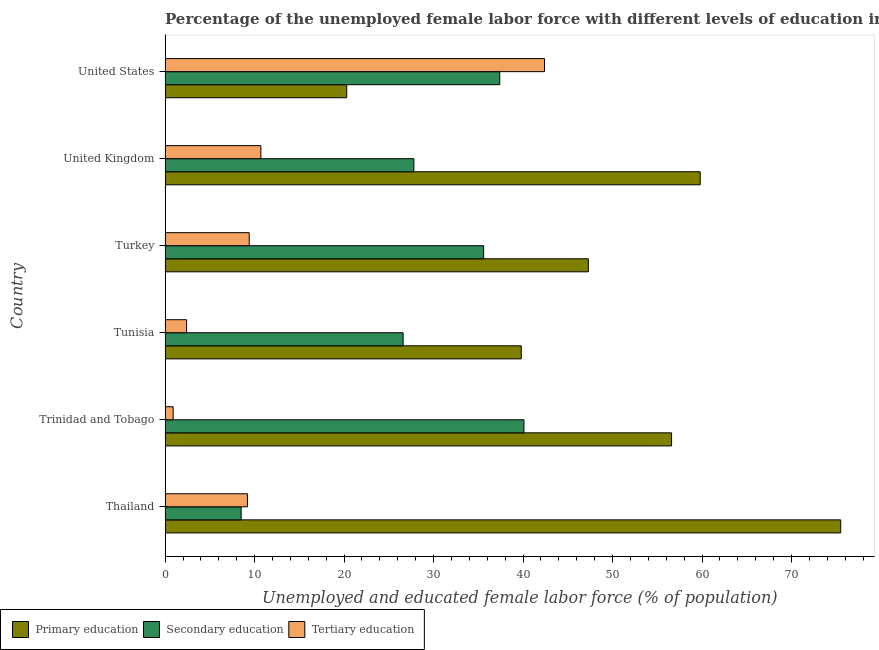How many different coloured bars are there?
Keep it short and to the point. 3. Are the number of bars per tick equal to the number of legend labels?
Your answer should be very brief. Yes. Are the number of bars on each tick of the Y-axis equal?
Give a very brief answer. Yes. In how many cases, is the number of bars for a given country not equal to the number of legend labels?
Provide a short and direct response. 0. What is the percentage of female labor force who received secondary education in Turkey?
Ensure brevity in your answer.  35.6. Across all countries, what is the maximum percentage of female labor force who received tertiary education?
Make the answer very short. 42.4. Across all countries, what is the minimum percentage of female labor force who received tertiary education?
Ensure brevity in your answer.  0.9. In which country was the percentage of female labor force who received primary education maximum?
Your answer should be very brief. Thailand. In which country was the percentage of female labor force who received secondary education minimum?
Provide a succinct answer. Thailand. What is the total percentage of female labor force who received tertiary education in the graph?
Your answer should be very brief. 75. What is the difference between the percentage of female labor force who received secondary education in Tunisia and that in United States?
Your answer should be compact. -10.8. What is the difference between the percentage of female labor force who received primary education in Thailand and the percentage of female labor force who received secondary education in United States?
Give a very brief answer. 38.1. What is the average percentage of female labor force who received primary education per country?
Your answer should be compact. 49.88. What is the difference between the percentage of female labor force who received tertiary education and percentage of female labor force who received primary education in Turkey?
Provide a succinct answer. -37.9. What is the ratio of the percentage of female labor force who received tertiary education in Tunisia to that in Turkey?
Ensure brevity in your answer.  0.26. Is the percentage of female labor force who received secondary education in Tunisia less than that in United States?
Provide a short and direct response. Yes. What is the difference between the highest and the second highest percentage of female labor force who received tertiary education?
Ensure brevity in your answer.  31.7. What is the difference between the highest and the lowest percentage of female labor force who received primary education?
Your answer should be very brief. 55.2. In how many countries, is the percentage of female labor force who received tertiary education greater than the average percentage of female labor force who received tertiary education taken over all countries?
Provide a succinct answer. 1. Is the sum of the percentage of female labor force who received primary education in Thailand and Tunisia greater than the maximum percentage of female labor force who received secondary education across all countries?
Provide a short and direct response. Yes. What does the 3rd bar from the top in Tunisia represents?
Give a very brief answer. Primary education. What does the 1st bar from the bottom in Tunisia represents?
Provide a short and direct response. Primary education. Is it the case that in every country, the sum of the percentage of female labor force who received primary education and percentage of female labor force who received secondary education is greater than the percentage of female labor force who received tertiary education?
Your response must be concise. Yes. How many bars are there?
Ensure brevity in your answer.  18. Are all the bars in the graph horizontal?
Your answer should be very brief. Yes. How many countries are there in the graph?
Provide a short and direct response. 6. What is the difference between two consecutive major ticks on the X-axis?
Offer a very short reply. 10. Does the graph contain any zero values?
Provide a short and direct response. No. Where does the legend appear in the graph?
Your answer should be very brief. Bottom left. What is the title of the graph?
Offer a terse response. Percentage of the unemployed female labor force with different levels of education in countries. What is the label or title of the X-axis?
Your response must be concise. Unemployed and educated female labor force (% of population). What is the label or title of the Y-axis?
Your answer should be very brief. Country. What is the Unemployed and educated female labor force (% of population) of Primary education in Thailand?
Keep it short and to the point. 75.5. What is the Unemployed and educated female labor force (% of population) of Secondary education in Thailand?
Your response must be concise. 8.5. What is the Unemployed and educated female labor force (% of population) in Tertiary education in Thailand?
Offer a very short reply. 9.2. What is the Unemployed and educated female labor force (% of population) in Primary education in Trinidad and Tobago?
Your answer should be compact. 56.6. What is the Unemployed and educated female labor force (% of population) in Secondary education in Trinidad and Tobago?
Keep it short and to the point. 40.1. What is the Unemployed and educated female labor force (% of population) of Tertiary education in Trinidad and Tobago?
Offer a very short reply. 0.9. What is the Unemployed and educated female labor force (% of population) of Primary education in Tunisia?
Offer a terse response. 39.8. What is the Unemployed and educated female labor force (% of population) of Secondary education in Tunisia?
Your response must be concise. 26.6. What is the Unemployed and educated female labor force (% of population) in Tertiary education in Tunisia?
Offer a terse response. 2.4. What is the Unemployed and educated female labor force (% of population) of Primary education in Turkey?
Keep it short and to the point. 47.3. What is the Unemployed and educated female labor force (% of population) of Secondary education in Turkey?
Your answer should be compact. 35.6. What is the Unemployed and educated female labor force (% of population) in Tertiary education in Turkey?
Offer a terse response. 9.4. What is the Unemployed and educated female labor force (% of population) in Primary education in United Kingdom?
Give a very brief answer. 59.8. What is the Unemployed and educated female labor force (% of population) of Secondary education in United Kingdom?
Offer a terse response. 27.8. What is the Unemployed and educated female labor force (% of population) of Tertiary education in United Kingdom?
Your answer should be very brief. 10.7. What is the Unemployed and educated female labor force (% of population) of Primary education in United States?
Offer a terse response. 20.3. What is the Unemployed and educated female labor force (% of population) of Secondary education in United States?
Offer a very short reply. 37.4. What is the Unemployed and educated female labor force (% of population) of Tertiary education in United States?
Your answer should be compact. 42.4. Across all countries, what is the maximum Unemployed and educated female labor force (% of population) of Primary education?
Give a very brief answer. 75.5. Across all countries, what is the maximum Unemployed and educated female labor force (% of population) in Secondary education?
Your response must be concise. 40.1. Across all countries, what is the maximum Unemployed and educated female labor force (% of population) of Tertiary education?
Ensure brevity in your answer.  42.4. Across all countries, what is the minimum Unemployed and educated female labor force (% of population) in Primary education?
Offer a terse response. 20.3. Across all countries, what is the minimum Unemployed and educated female labor force (% of population) of Tertiary education?
Offer a very short reply. 0.9. What is the total Unemployed and educated female labor force (% of population) in Primary education in the graph?
Ensure brevity in your answer.  299.3. What is the total Unemployed and educated female labor force (% of population) of Secondary education in the graph?
Ensure brevity in your answer.  176. What is the difference between the Unemployed and educated female labor force (% of population) in Primary education in Thailand and that in Trinidad and Tobago?
Your answer should be compact. 18.9. What is the difference between the Unemployed and educated female labor force (% of population) of Secondary education in Thailand and that in Trinidad and Tobago?
Give a very brief answer. -31.6. What is the difference between the Unemployed and educated female labor force (% of population) in Tertiary education in Thailand and that in Trinidad and Tobago?
Your answer should be very brief. 8.3. What is the difference between the Unemployed and educated female labor force (% of population) in Primary education in Thailand and that in Tunisia?
Keep it short and to the point. 35.7. What is the difference between the Unemployed and educated female labor force (% of population) of Secondary education in Thailand and that in Tunisia?
Ensure brevity in your answer.  -18.1. What is the difference between the Unemployed and educated female labor force (% of population) of Primary education in Thailand and that in Turkey?
Keep it short and to the point. 28.2. What is the difference between the Unemployed and educated female labor force (% of population) in Secondary education in Thailand and that in Turkey?
Make the answer very short. -27.1. What is the difference between the Unemployed and educated female labor force (% of population) in Tertiary education in Thailand and that in Turkey?
Offer a terse response. -0.2. What is the difference between the Unemployed and educated female labor force (% of population) of Secondary education in Thailand and that in United Kingdom?
Offer a very short reply. -19.3. What is the difference between the Unemployed and educated female labor force (% of population) in Tertiary education in Thailand and that in United Kingdom?
Offer a very short reply. -1.5. What is the difference between the Unemployed and educated female labor force (% of population) of Primary education in Thailand and that in United States?
Your answer should be compact. 55.2. What is the difference between the Unemployed and educated female labor force (% of population) of Secondary education in Thailand and that in United States?
Give a very brief answer. -28.9. What is the difference between the Unemployed and educated female labor force (% of population) in Tertiary education in Thailand and that in United States?
Make the answer very short. -33.2. What is the difference between the Unemployed and educated female labor force (% of population) of Primary education in Trinidad and Tobago and that in Tunisia?
Your response must be concise. 16.8. What is the difference between the Unemployed and educated female labor force (% of population) in Secondary education in Trinidad and Tobago and that in Tunisia?
Your response must be concise. 13.5. What is the difference between the Unemployed and educated female labor force (% of population) in Tertiary education in Trinidad and Tobago and that in Turkey?
Your answer should be compact. -8.5. What is the difference between the Unemployed and educated female labor force (% of population) of Secondary education in Trinidad and Tobago and that in United Kingdom?
Ensure brevity in your answer.  12.3. What is the difference between the Unemployed and educated female labor force (% of population) of Tertiary education in Trinidad and Tobago and that in United Kingdom?
Give a very brief answer. -9.8. What is the difference between the Unemployed and educated female labor force (% of population) of Primary education in Trinidad and Tobago and that in United States?
Ensure brevity in your answer.  36.3. What is the difference between the Unemployed and educated female labor force (% of population) of Tertiary education in Trinidad and Tobago and that in United States?
Provide a short and direct response. -41.5. What is the difference between the Unemployed and educated female labor force (% of population) in Tertiary education in Tunisia and that in Turkey?
Make the answer very short. -7. What is the difference between the Unemployed and educated female labor force (% of population) of Primary education in Tunisia and that in United Kingdom?
Ensure brevity in your answer.  -20. What is the difference between the Unemployed and educated female labor force (% of population) of Tertiary education in Tunisia and that in United Kingdom?
Your answer should be very brief. -8.3. What is the difference between the Unemployed and educated female labor force (% of population) in Tertiary education in Tunisia and that in United States?
Give a very brief answer. -40. What is the difference between the Unemployed and educated female labor force (% of population) in Primary education in Turkey and that in United Kingdom?
Offer a terse response. -12.5. What is the difference between the Unemployed and educated female labor force (% of population) of Secondary education in Turkey and that in United Kingdom?
Provide a short and direct response. 7.8. What is the difference between the Unemployed and educated female labor force (% of population) of Secondary education in Turkey and that in United States?
Your answer should be very brief. -1.8. What is the difference between the Unemployed and educated female labor force (% of population) of Tertiary education in Turkey and that in United States?
Keep it short and to the point. -33. What is the difference between the Unemployed and educated female labor force (% of population) of Primary education in United Kingdom and that in United States?
Give a very brief answer. 39.5. What is the difference between the Unemployed and educated female labor force (% of population) of Tertiary education in United Kingdom and that in United States?
Your response must be concise. -31.7. What is the difference between the Unemployed and educated female labor force (% of population) in Primary education in Thailand and the Unemployed and educated female labor force (% of population) in Secondary education in Trinidad and Tobago?
Your answer should be compact. 35.4. What is the difference between the Unemployed and educated female labor force (% of population) of Primary education in Thailand and the Unemployed and educated female labor force (% of population) of Tertiary education in Trinidad and Tobago?
Offer a very short reply. 74.6. What is the difference between the Unemployed and educated female labor force (% of population) of Secondary education in Thailand and the Unemployed and educated female labor force (% of population) of Tertiary education in Trinidad and Tobago?
Offer a very short reply. 7.6. What is the difference between the Unemployed and educated female labor force (% of population) of Primary education in Thailand and the Unemployed and educated female labor force (% of population) of Secondary education in Tunisia?
Your response must be concise. 48.9. What is the difference between the Unemployed and educated female labor force (% of population) in Primary education in Thailand and the Unemployed and educated female labor force (% of population) in Tertiary education in Tunisia?
Ensure brevity in your answer.  73.1. What is the difference between the Unemployed and educated female labor force (% of population) in Primary education in Thailand and the Unemployed and educated female labor force (% of population) in Secondary education in Turkey?
Provide a short and direct response. 39.9. What is the difference between the Unemployed and educated female labor force (% of population) in Primary education in Thailand and the Unemployed and educated female labor force (% of population) in Tertiary education in Turkey?
Ensure brevity in your answer.  66.1. What is the difference between the Unemployed and educated female labor force (% of population) of Primary education in Thailand and the Unemployed and educated female labor force (% of population) of Secondary education in United Kingdom?
Provide a short and direct response. 47.7. What is the difference between the Unemployed and educated female labor force (% of population) of Primary education in Thailand and the Unemployed and educated female labor force (% of population) of Tertiary education in United Kingdom?
Give a very brief answer. 64.8. What is the difference between the Unemployed and educated female labor force (% of population) of Secondary education in Thailand and the Unemployed and educated female labor force (% of population) of Tertiary education in United Kingdom?
Provide a short and direct response. -2.2. What is the difference between the Unemployed and educated female labor force (% of population) in Primary education in Thailand and the Unemployed and educated female labor force (% of population) in Secondary education in United States?
Make the answer very short. 38.1. What is the difference between the Unemployed and educated female labor force (% of population) of Primary education in Thailand and the Unemployed and educated female labor force (% of population) of Tertiary education in United States?
Your answer should be compact. 33.1. What is the difference between the Unemployed and educated female labor force (% of population) of Secondary education in Thailand and the Unemployed and educated female labor force (% of population) of Tertiary education in United States?
Offer a terse response. -33.9. What is the difference between the Unemployed and educated female labor force (% of population) of Primary education in Trinidad and Tobago and the Unemployed and educated female labor force (% of population) of Tertiary education in Tunisia?
Provide a succinct answer. 54.2. What is the difference between the Unemployed and educated female labor force (% of population) in Secondary education in Trinidad and Tobago and the Unemployed and educated female labor force (% of population) in Tertiary education in Tunisia?
Your answer should be compact. 37.7. What is the difference between the Unemployed and educated female labor force (% of population) in Primary education in Trinidad and Tobago and the Unemployed and educated female labor force (% of population) in Secondary education in Turkey?
Provide a short and direct response. 21. What is the difference between the Unemployed and educated female labor force (% of population) of Primary education in Trinidad and Tobago and the Unemployed and educated female labor force (% of population) of Tertiary education in Turkey?
Your response must be concise. 47.2. What is the difference between the Unemployed and educated female labor force (% of population) of Secondary education in Trinidad and Tobago and the Unemployed and educated female labor force (% of population) of Tertiary education in Turkey?
Offer a very short reply. 30.7. What is the difference between the Unemployed and educated female labor force (% of population) of Primary education in Trinidad and Tobago and the Unemployed and educated female labor force (% of population) of Secondary education in United Kingdom?
Your response must be concise. 28.8. What is the difference between the Unemployed and educated female labor force (% of population) in Primary education in Trinidad and Tobago and the Unemployed and educated female labor force (% of population) in Tertiary education in United Kingdom?
Provide a succinct answer. 45.9. What is the difference between the Unemployed and educated female labor force (% of population) of Secondary education in Trinidad and Tobago and the Unemployed and educated female labor force (% of population) of Tertiary education in United Kingdom?
Your answer should be compact. 29.4. What is the difference between the Unemployed and educated female labor force (% of population) in Primary education in Trinidad and Tobago and the Unemployed and educated female labor force (% of population) in Secondary education in United States?
Your answer should be compact. 19.2. What is the difference between the Unemployed and educated female labor force (% of population) in Primary education in Trinidad and Tobago and the Unemployed and educated female labor force (% of population) in Tertiary education in United States?
Give a very brief answer. 14.2. What is the difference between the Unemployed and educated female labor force (% of population) in Primary education in Tunisia and the Unemployed and educated female labor force (% of population) in Tertiary education in Turkey?
Give a very brief answer. 30.4. What is the difference between the Unemployed and educated female labor force (% of population) in Primary education in Tunisia and the Unemployed and educated female labor force (% of population) in Secondary education in United Kingdom?
Your answer should be compact. 12. What is the difference between the Unemployed and educated female labor force (% of population) of Primary education in Tunisia and the Unemployed and educated female labor force (% of population) of Tertiary education in United Kingdom?
Offer a very short reply. 29.1. What is the difference between the Unemployed and educated female labor force (% of population) in Secondary education in Tunisia and the Unemployed and educated female labor force (% of population) in Tertiary education in United Kingdom?
Your answer should be compact. 15.9. What is the difference between the Unemployed and educated female labor force (% of population) in Primary education in Tunisia and the Unemployed and educated female labor force (% of population) in Secondary education in United States?
Provide a succinct answer. 2.4. What is the difference between the Unemployed and educated female labor force (% of population) in Primary education in Tunisia and the Unemployed and educated female labor force (% of population) in Tertiary education in United States?
Your response must be concise. -2.6. What is the difference between the Unemployed and educated female labor force (% of population) in Secondary education in Tunisia and the Unemployed and educated female labor force (% of population) in Tertiary education in United States?
Offer a terse response. -15.8. What is the difference between the Unemployed and educated female labor force (% of population) of Primary education in Turkey and the Unemployed and educated female labor force (% of population) of Secondary education in United Kingdom?
Give a very brief answer. 19.5. What is the difference between the Unemployed and educated female labor force (% of population) of Primary education in Turkey and the Unemployed and educated female labor force (% of population) of Tertiary education in United Kingdom?
Make the answer very short. 36.6. What is the difference between the Unemployed and educated female labor force (% of population) of Secondary education in Turkey and the Unemployed and educated female labor force (% of population) of Tertiary education in United Kingdom?
Give a very brief answer. 24.9. What is the difference between the Unemployed and educated female labor force (% of population) in Primary education in Turkey and the Unemployed and educated female labor force (% of population) in Tertiary education in United States?
Make the answer very short. 4.9. What is the difference between the Unemployed and educated female labor force (% of population) in Primary education in United Kingdom and the Unemployed and educated female labor force (% of population) in Secondary education in United States?
Your response must be concise. 22.4. What is the difference between the Unemployed and educated female labor force (% of population) in Primary education in United Kingdom and the Unemployed and educated female labor force (% of population) in Tertiary education in United States?
Make the answer very short. 17.4. What is the difference between the Unemployed and educated female labor force (% of population) in Secondary education in United Kingdom and the Unemployed and educated female labor force (% of population) in Tertiary education in United States?
Make the answer very short. -14.6. What is the average Unemployed and educated female labor force (% of population) of Primary education per country?
Your response must be concise. 49.88. What is the average Unemployed and educated female labor force (% of population) of Secondary education per country?
Ensure brevity in your answer.  29.33. What is the difference between the Unemployed and educated female labor force (% of population) in Primary education and Unemployed and educated female labor force (% of population) in Secondary education in Thailand?
Your answer should be very brief. 67. What is the difference between the Unemployed and educated female labor force (% of population) of Primary education and Unemployed and educated female labor force (% of population) of Tertiary education in Thailand?
Offer a very short reply. 66.3. What is the difference between the Unemployed and educated female labor force (% of population) of Primary education and Unemployed and educated female labor force (% of population) of Secondary education in Trinidad and Tobago?
Your response must be concise. 16.5. What is the difference between the Unemployed and educated female labor force (% of population) of Primary education and Unemployed and educated female labor force (% of population) of Tertiary education in Trinidad and Tobago?
Give a very brief answer. 55.7. What is the difference between the Unemployed and educated female labor force (% of population) of Secondary education and Unemployed and educated female labor force (% of population) of Tertiary education in Trinidad and Tobago?
Give a very brief answer. 39.2. What is the difference between the Unemployed and educated female labor force (% of population) of Primary education and Unemployed and educated female labor force (% of population) of Tertiary education in Tunisia?
Provide a short and direct response. 37.4. What is the difference between the Unemployed and educated female labor force (% of population) of Secondary education and Unemployed and educated female labor force (% of population) of Tertiary education in Tunisia?
Offer a very short reply. 24.2. What is the difference between the Unemployed and educated female labor force (% of population) of Primary education and Unemployed and educated female labor force (% of population) of Tertiary education in Turkey?
Your response must be concise. 37.9. What is the difference between the Unemployed and educated female labor force (% of population) in Secondary education and Unemployed and educated female labor force (% of population) in Tertiary education in Turkey?
Keep it short and to the point. 26.2. What is the difference between the Unemployed and educated female labor force (% of population) in Primary education and Unemployed and educated female labor force (% of population) in Tertiary education in United Kingdom?
Your answer should be compact. 49.1. What is the difference between the Unemployed and educated female labor force (% of population) of Primary education and Unemployed and educated female labor force (% of population) of Secondary education in United States?
Give a very brief answer. -17.1. What is the difference between the Unemployed and educated female labor force (% of population) in Primary education and Unemployed and educated female labor force (% of population) in Tertiary education in United States?
Provide a short and direct response. -22.1. What is the ratio of the Unemployed and educated female labor force (% of population) in Primary education in Thailand to that in Trinidad and Tobago?
Make the answer very short. 1.33. What is the ratio of the Unemployed and educated female labor force (% of population) in Secondary education in Thailand to that in Trinidad and Tobago?
Provide a short and direct response. 0.21. What is the ratio of the Unemployed and educated female labor force (% of population) in Tertiary education in Thailand to that in Trinidad and Tobago?
Your answer should be very brief. 10.22. What is the ratio of the Unemployed and educated female labor force (% of population) in Primary education in Thailand to that in Tunisia?
Keep it short and to the point. 1.9. What is the ratio of the Unemployed and educated female labor force (% of population) of Secondary education in Thailand to that in Tunisia?
Provide a short and direct response. 0.32. What is the ratio of the Unemployed and educated female labor force (% of population) in Tertiary education in Thailand to that in Tunisia?
Offer a terse response. 3.83. What is the ratio of the Unemployed and educated female labor force (% of population) of Primary education in Thailand to that in Turkey?
Provide a short and direct response. 1.6. What is the ratio of the Unemployed and educated female labor force (% of population) of Secondary education in Thailand to that in Turkey?
Offer a terse response. 0.24. What is the ratio of the Unemployed and educated female labor force (% of population) in Tertiary education in Thailand to that in Turkey?
Provide a short and direct response. 0.98. What is the ratio of the Unemployed and educated female labor force (% of population) in Primary education in Thailand to that in United Kingdom?
Give a very brief answer. 1.26. What is the ratio of the Unemployed and educated female labor force (% of population) of Secondary education in Thailand to that in United Kingdom?
Provide a short and direct response. 0.31. What is the ratio of the Unemployed and educated female labor force (% of population) in Tertiary education in Thailand to that in United Kingdom?
Your answer should be compact. 0.86. What is the ratio of the Unemployed and educated female labor force (% of population) of Primary education in Thailand to that in United States?
Offer a very short reply. 3.72. What is the ratio of the Unemployed and educated female labor force (% of population) of Secondary education in Thailand to that in United States?
Provide a short and direct response. 0.23. What is the ratio of the Unemployed and educated female labor force (% of population) of Tertiary education in Thailand to that in United States?
Your answer should be compact. 0.22. What is the ratio of the Unemployed and educated female labor force (% of population) in Primary education in Trinidad and Tobago to that in Tunisia?
Make the answer very short. 1.42. What is the ratio of the Unemployed and educated female labor force (% of population) in Secondary education in Trinidad and Tobago to that in Tunisia?
Offer a very short reply. 1.51. What is the ratio of the Unemployed and educated female labor force (% of population) of Primary education in Trinidad and Tobago to that in Turkey?
Keep it short and to the point. 1.2. What is the ratio of the Unemployed and educated female labor force (% of population) of Secondary education in Trinidad and Tobago to that in Turkey?
Give a very brief answer. 1.13. What is the ratio of the Unemployed and educated female labor force (% of population) of Tertiary education in Trinidad and Tobago to that in Turkey?
Offer a terse response. 0.1. What is the ratio of the Unemployed and educated female labor force (% of population) of Primary education in Trinidad and Tobago to that in United Kingdom?
Provide a short and direct response. 0.95. What is the ratio of the Unemployed and educated female labor force (% of population) of Secondary education in Trinidad and Tobago to that in United Kingdom?
Offer a terse response. 1.44. What is the ratio of the Unemployed and educated female labor force (% of population) of Tertiary education in Trinidad and Tobago to that in United Kingdom?
Keep it short and to the point. 0.08. What is the ratio of the Unemployed and educated female labor force (% of population) of Primary education in Trinidad and Tobago to that in United States?
Make the answer very short. 2.79. What is the ratio of the Unemployed and educated female labor force (% of population) of Secondary education in Trinidad and Tobago to that in United States?
Offer a terse response. 1.07. What is the ratio of the Unemployed and educated female labor force (% of population) in Tertiary education in Trinidad and Tobago to that in United States?
Your answer should be compact. 0.02. What is the ratio of the Unemployed and educated female labor force (% of population) in Primary education in Tunisia to that in Turkey?
Make the answer very short. 0.84. What is the ratio of the Unemployed and educated female labor force (% of population) in Secondary education in Tunisia to that in Turkey?
Offer a very short reply. 0.75. What is the ratio of the Unemployed and educated female labor force (% of population) of Tertiary education in Tunisia to that in Turkey?
Give a very brief answer. 0.26. What is the ratio of the Unemployed and educated female labor force (% of population) of Primary education in Tunisia to that in United Kingdom?
Offer a terse response. 0.67. What is the ratio of the Unemployed and educated female labor force (% of population) of Secondary education in Tunisia to that in United Kingdom?
Your response must be concise. 0.96. What is the ratio of the Unemployed and educated female labor force (% of population) in Tertiary education in Tunisia to that in United Kingdom?
Offer a terse response. 0.22. What is the ratio of the Unemployed and educated female labor force (% of population) of Primary education in Tunisia to that in United States?
Your answer should be very brief. 1.96. What is the ratio of the Unemployed and educated female labor force (% of population) of Secondary education in Tunisia to that in United States?
Keep it short and to the point. 0.71. What is the ratio of the Unemployed and educated female labor force (% of population) of Tertiary education in Tunisia to that in United States?
Your response must be concise. 0.06. What is the ratio of the Unemployed and educated female labor force (% of population) in Primary education in Turkey to that in United Kingdom?
Your response must be concise. 0.79. What is the ratio of the Unemployed and educated female labor force (% of population) in Secondary education in Turkey to that in United Kingdom?
Offer a terse response. 1.28. What is the ratio of the Unemployed and educated female labor force (% of population) of Tertiary education in Turkey to that in United Kingdom?
Offer a very short reply. 0.88. What is the ratio of the Unemployed and educated female labor force (% of population) of Primary education in Turkey to that in United States?
Ensure brevity in your answer.  2.33. What is the ratio of the Unemployed and educated female labor force (% of population) of Secondary education in Turkey to that in United States?
Keep it short and to the point. 0.95. What is the ratio of the Unemployed and educated female labor force (% of population) of Tertiary education in Turkey to that in United States?
Make the answer very short. 0.22. What is the ratio of the Unemployed and educated female labor force (% of population) in Primary education in United Kingdom to that in United States?
Give a very brief answer. 2.95. What is the ratio of the Unemployed and educated female labor force (% of population) of Secondary education in United Kingdom to that in United States?
Offer a terse response. 0.74. What is the ratio of the Unemployed and educated female labor force (% of population) of Tertiary education in United Kingdom to that in United States?
Ensure brevity in your answer.  0.25. What is the difference between the highest and the second highest Unemployed and educated female labor force (% of population) in Primary education?
Ensure brevity in your answer.  15.7. What is the difference between the highest and the second highest Unemployed and educated female labor force (% of population) of Secondary education?
Offer a very short reply. 2.7. What is the difference between the highest and the second highest Unemployed and educated female labor force (% of population) of Tertiary education?
Give a very brief answer. 31.7. What is the difference between the highest and the lowest Unemployed and educated female labor force (% of population) of Primary education?
Your answer should be very brief. 55.2. What is the difference between the highest and the lowest Unemployed and educated female labor force (% of population) in Secondary education?
Your answer should be very brief. 31.6. What is the difference between the highest and the lowest Unemployed and educated female labor force (% of population) of Tertiary education?
Give a very brief answer. 41.5. 